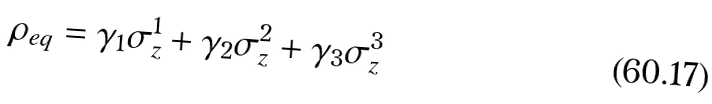<formula> <loc_0><loc_0><loc_500><loc_500>\rho _ { e q } = \gamma _ { 1 } \sigma _ { z } ^ { 1 } + \gamma _ { 2 } \sigma _ { z } ^ { 2 } + \gamma _ { 3 } \sigma _ { z } ^ { 3 }</formula> 